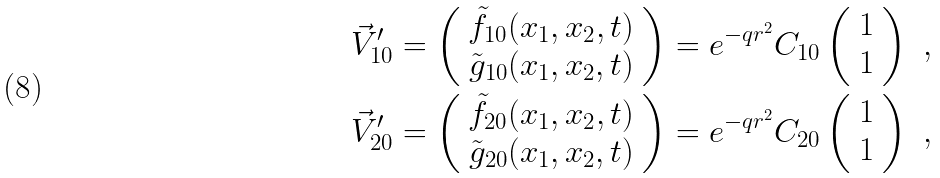Convert formula to latex. <formula><loc_0><loc_0><loc_500><loc_500>\vec { V } ^ { \prime } _ { 1 0 } = \left ( \begin{array} { c } \tilde { f } _ { 1 0 } ( x _ { 1 } , x _ { 2 } , t ) \\ \tilde { g } _ { 1 0 } ( x _ { 1 } , x _ { 2 } , t ) \end{array} \right ) = e ^ { - q r ^ { 2 } } C _ { 1 0 } \left ( \begin{array} { c } 1 \\ 1 \end{array} \right ) \ , \\ \vec { V } ^ { \prime } _ { 2 0 } = \left ( \begin{array} { c } \tilde { f } _ { 2 0 } ( x _ { 1 } , x _ { 2 } , t ) \\ \tilde { g } _ { 2 0 } ( x _ { 1 } , x _ { 2 } , t ) \end{array} \right ) = e ^ { - q r ^ { 2 } } C _ { 2 0 } \left ( \begin{array} { c } 1 \\ 1 \end{array} \right ) \ ,</formula> 